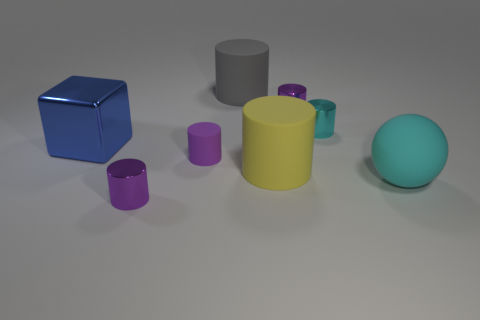Is the color of the shiny thing in front of the large shiny cube the same as the large rubber thing on the left side of the big yellow rubber cylinder?
Keep it short and to the point. No. Are there any metal cylinders that are behind the big matte cylinder in front of the large gray matte thing?
Provide a succinct answer. Yes. Is the shape of the tiny purple object to the right of the large gray cylinder the same as the thing that is to the right of the cyan metal thing?
Your answer should be very brief. No. Does the cyan cylinder that is on the right side of the large gray rubber cylinder have the same material as the large object behind the tiny cyan metallic cylinder?
Provide a succinct answer. No. The object to the left of the tiny metal thing that is in front of the large blue metallic object is made of what material?
Provide a succinct answer. Metal. The tiny purple metallic thing that is behind the small metal object that is in front of the yellow cylinder that is in front of the large gray thing is what shape?
Make the answer very short. Cylinder. There is a gray object that is the same shape as the large yellow object; what is it made of?
Keep it short and to the point. Rubber. What number of cyan rubber balls are there?
Offer a very short reply. 1. There is a large gray matte object behind the cube; what shape is it?
Offer a very short reply. Cylinder. What color is the small metallic thing to the right of the purple metallic cylinder that is to the right of the metal cylinder that is in front of the big cyan matte sphere?
Keep it short and to the point. Cyan. 